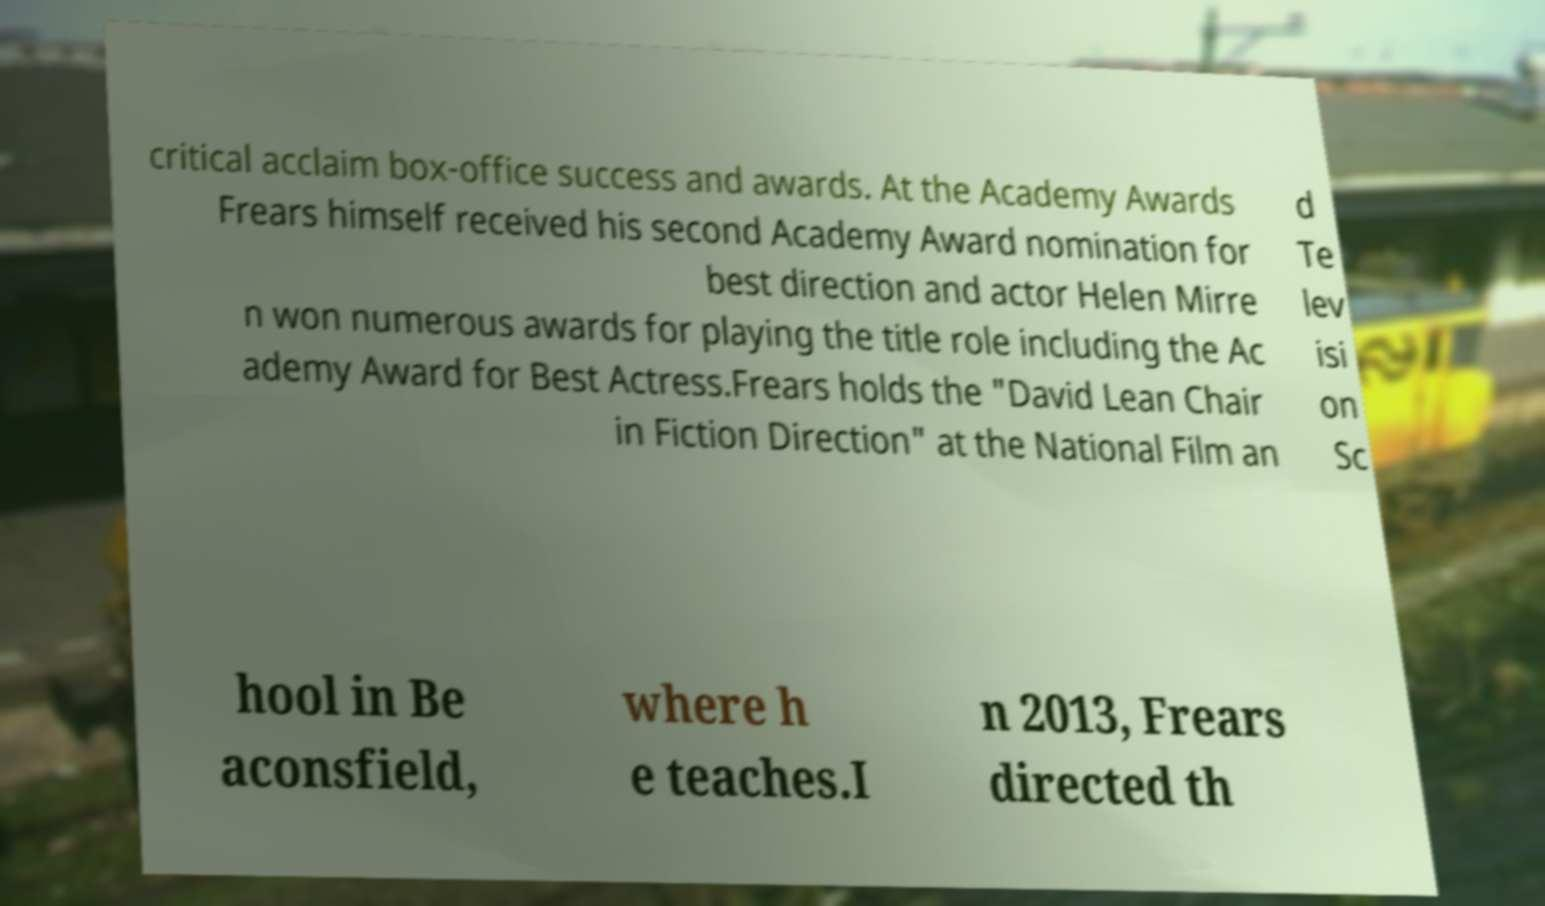Could you assist in decoding the text presented in this image and type it out clearly? critical acclaim box-office success and awards. At the Academy Awards Frears himself received his second Academy Award nomination for best direction and actor Helen Mirre n won numerous awards for playing the title role including the Ac ademy Award for Best Actress.Frears holds the "David Lean Chair in Fiction Direction" at the National Film an d Te lev isi on Sc hool in Be aconsfield, where h e teaches.I n 2013, Frears directed th 